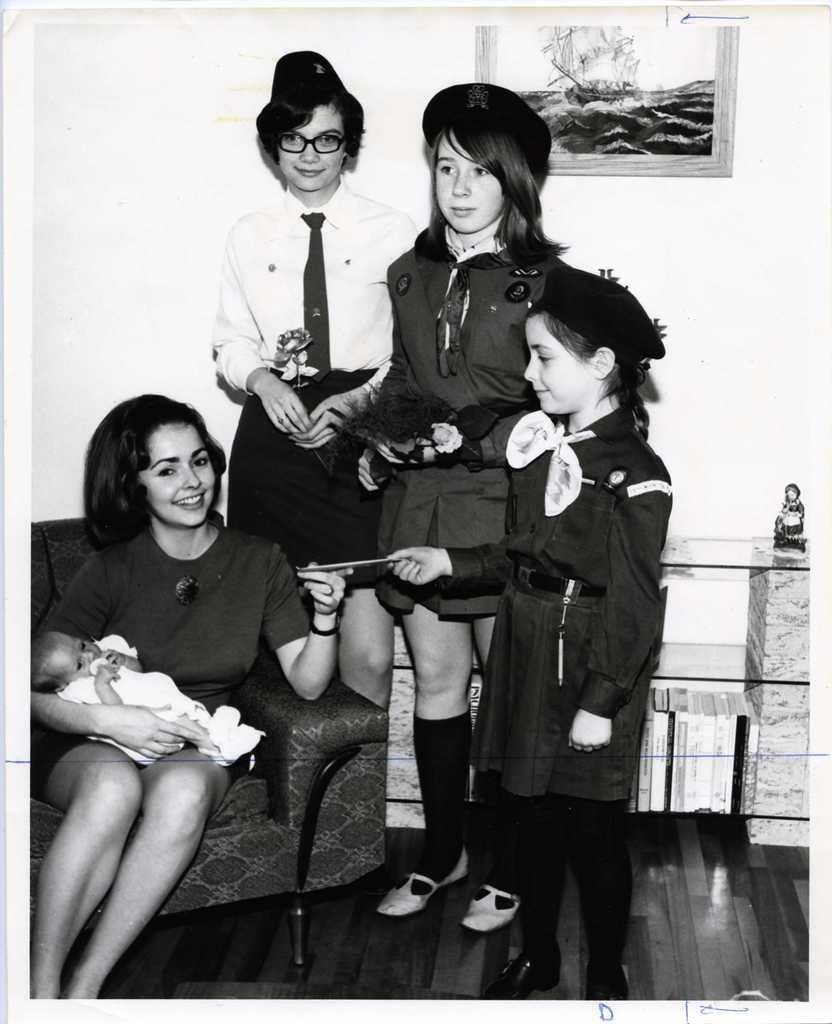Please provide a concise description of this image. In this image we can see a person sitting on a couch and carrying a baby. There is a photo on the wall. We can see few people standing and holding few objects in their hands. There are few objects placed on the rack at the right side of the image. 